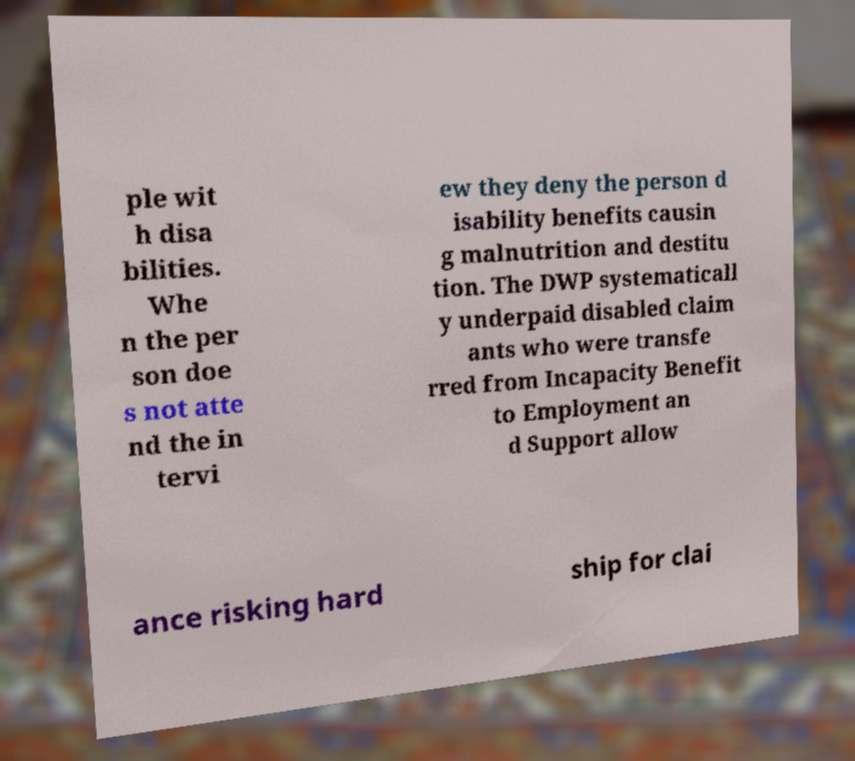I need the written content from this picture converted into text. Can you do that? ple wit h disa bilities. Whe n the per son doe s not atte nd the in tervi ew they deny the person d isability benefits causin g malnutrition and destitu tion. The DWP systematicall y underpaid disabled claim ants who were transfe rred from Incapacity Benefit to Employment an d Support allow ance risking hard ship for clai 